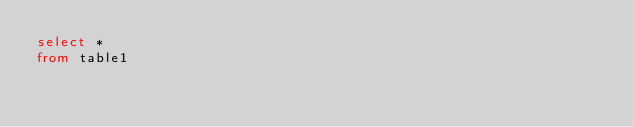Convert code to text. <code><loc_0><loc_0><loc_500><loc_500><_SQL_>select *
from table1</code> 